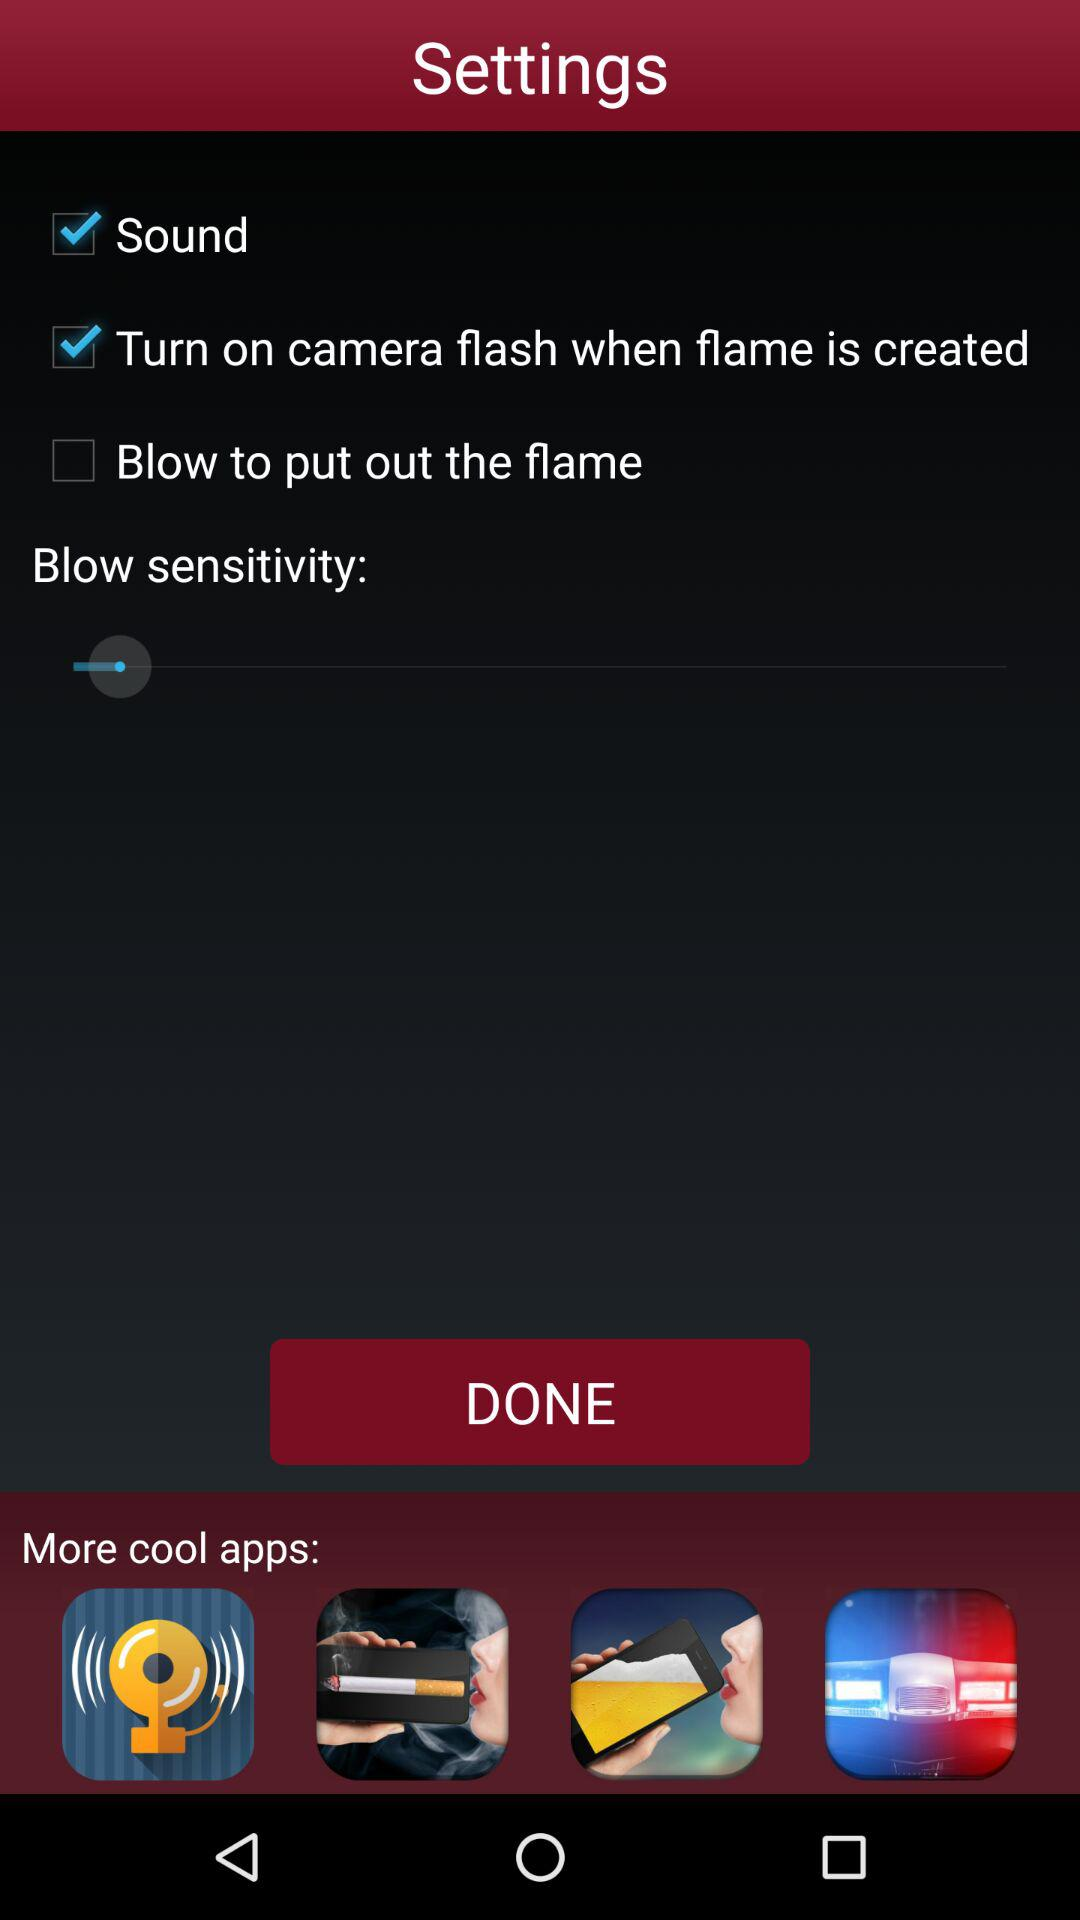How many steps are there in the instructions?
Answer the question using a single word or phrase. 4 